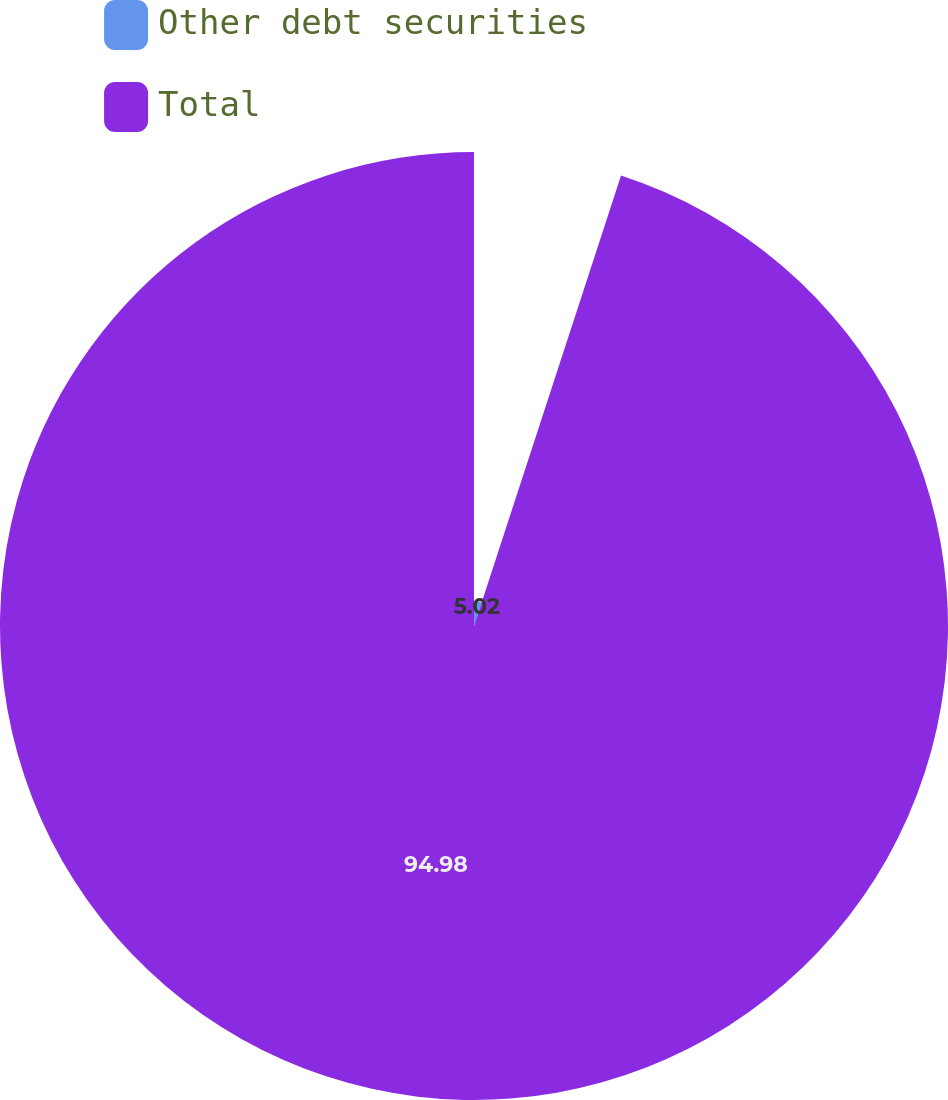<chart> <loc_0><loc_0><loc_500><loc_500><pie_chart><fcel>Other debt securities<fcel>Total<nl><fcel>5.02%<fcel>94.98%<nl></chart> 